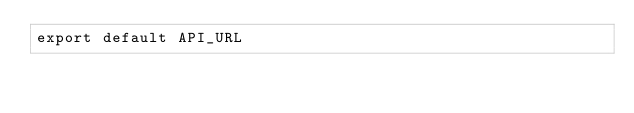<code> <loc_0><loc_0><loc_500><loc_500><_JavaScript_>export default API_URL
</code> 